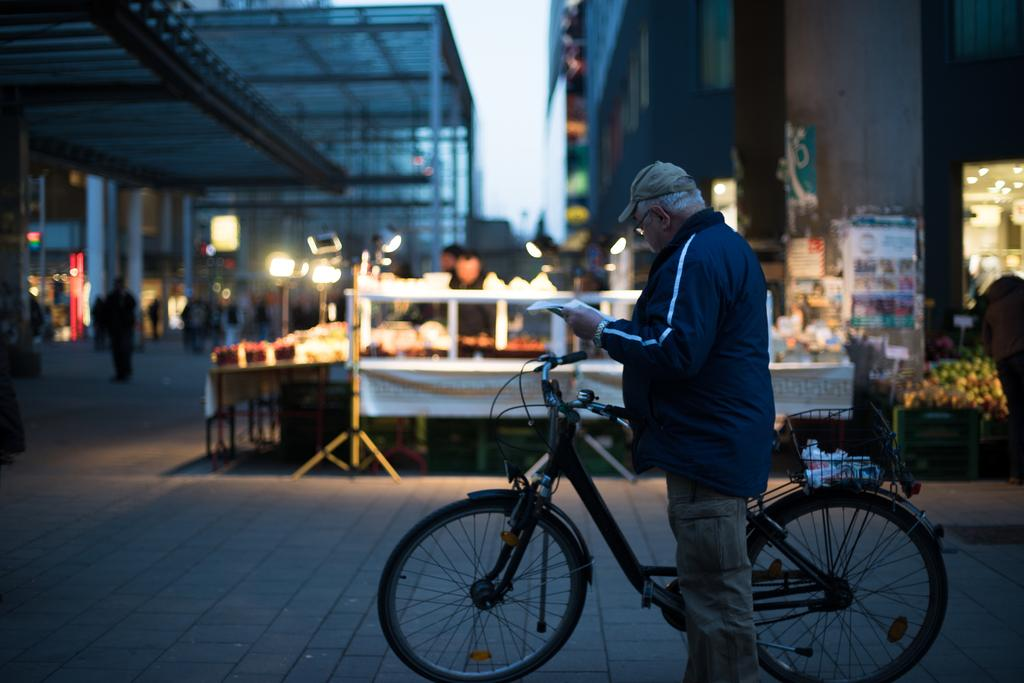What is the main subject of the image? There is a guy in the image. What is the guy holding in the image? The guy is holding a bicycle. What can be seen in the background of the image? There are stalls of food items and buildings in the background of the image. What season is the guy celebrating his birth in the image? There is no indication of a season or a birthday celebration in the image. 